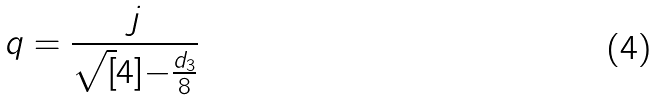<formula> <loc_0><loc_0><loc_500><loc_500>q = \frac { j } { \sqrt { [ } 4 ] { - \frac { d _ { 3 } } { 8 } } }</formula> 